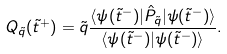<formula> <loc_0><loc_0><loc_500><loc_500>Q _ { \tilde { q } } ( \tilde { t } ^ { + } ) = { \tilde { q } } \frac { \langle \psi ( \tilde { t } ^ { - } ) | \hat { P } _ { \tilde { q } } | \psi ( \tilde { t } ^ { - } ) \rangle } { \langle \psi ( \tilde { t } ^ { - } ) | \psi ( \tilde { t } ^ { - } ) \rangle } .</formula> 